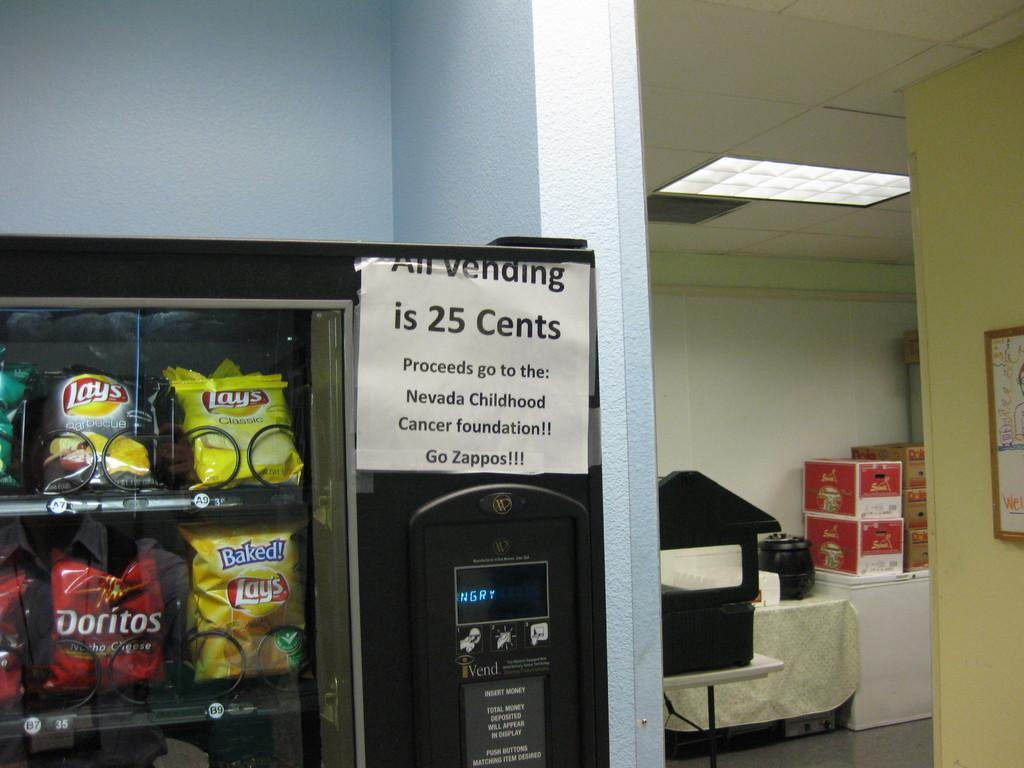<image>
Provide a brief description of the given image. The sign sends a lovely message telling people the proceeds go to a childhood cancer foundation. 